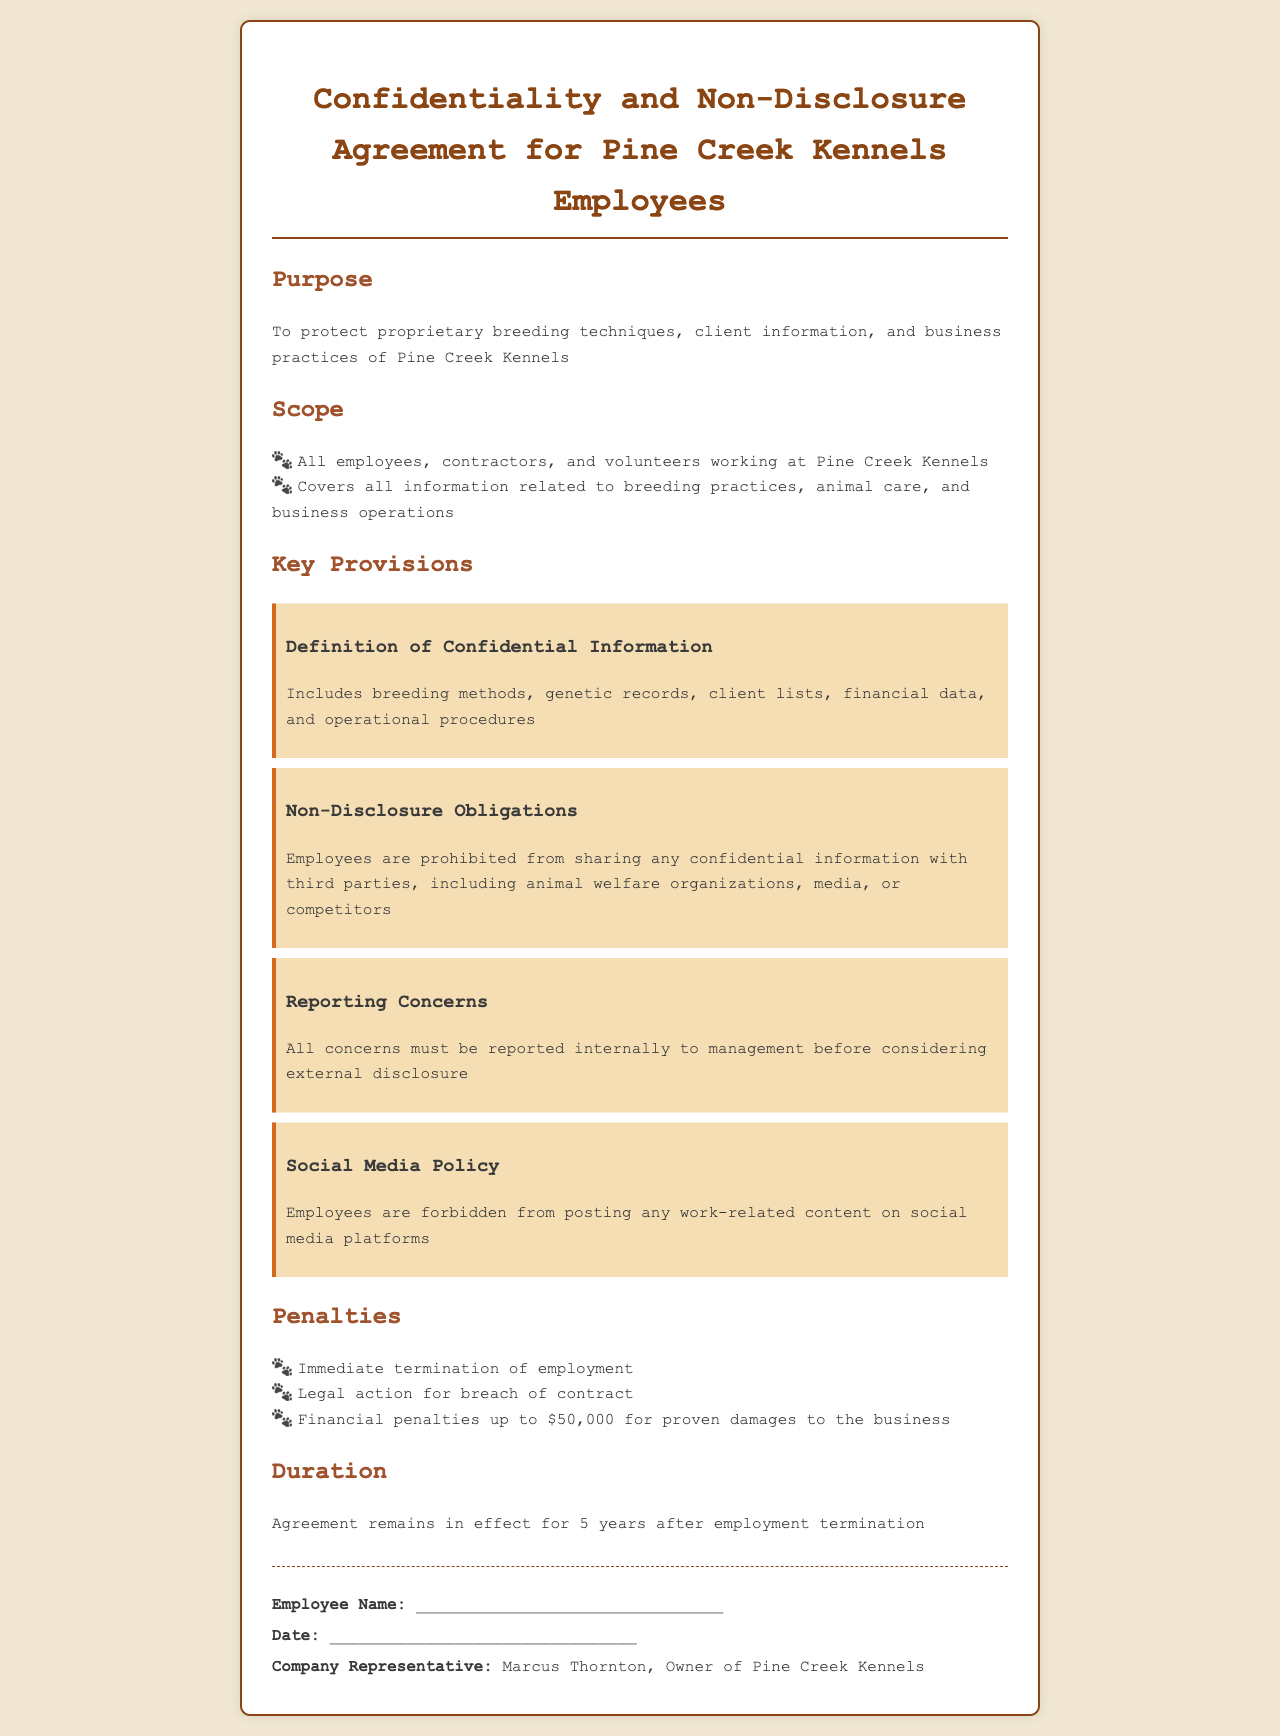What is the title of the document? The title of the document is stated in the header section.
Answer: Pine Creek Kennels Confidentiality Agreement Who is the company representative? The company representative is mentioned in the signature section of the document.
Answer: Marcus Thornton What is the duration of the agreement after employment termination? The document specifies how long the terms of the agreement are in effect after one leaves the company.
Answer: 5 years What are employees prohibited from sharing? This detail is outlined under non-disclosure obligations, indicating what information must remain confidential.
Answer: Confidential information What are the financial penalties for proven damages? The penalties section lists specific financial repercussions for breaches of the agreement.
Answer: $50,000 What must all concerns be reported to? The reporting concerns section indicates where to direct any issues regarding confidentiality.
Answer: Management What type of information is included under "Definition of Confidential Information"? This information is included in the key provisions section, detailing what falls under confidentiality.
Answer: Breeding methods, genetic records, client lists, financial data, and operational procedures What happens to employees who breach the agreement? The penalties section describes the consequences of violating the non-disclosure agreement.
Answer: Immediate termination of employment 